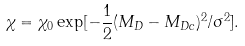Convert formula to latex. <formula><loc_0><loc_0><loc_500><loc_500>\chi = \chi _ { 0 } \exp [ - \frac { 1 } { 2 } ( M _ { D } - M _ { D c } ) ^ { 2 } / \sigma ^ { 2 } ] .</formula> 